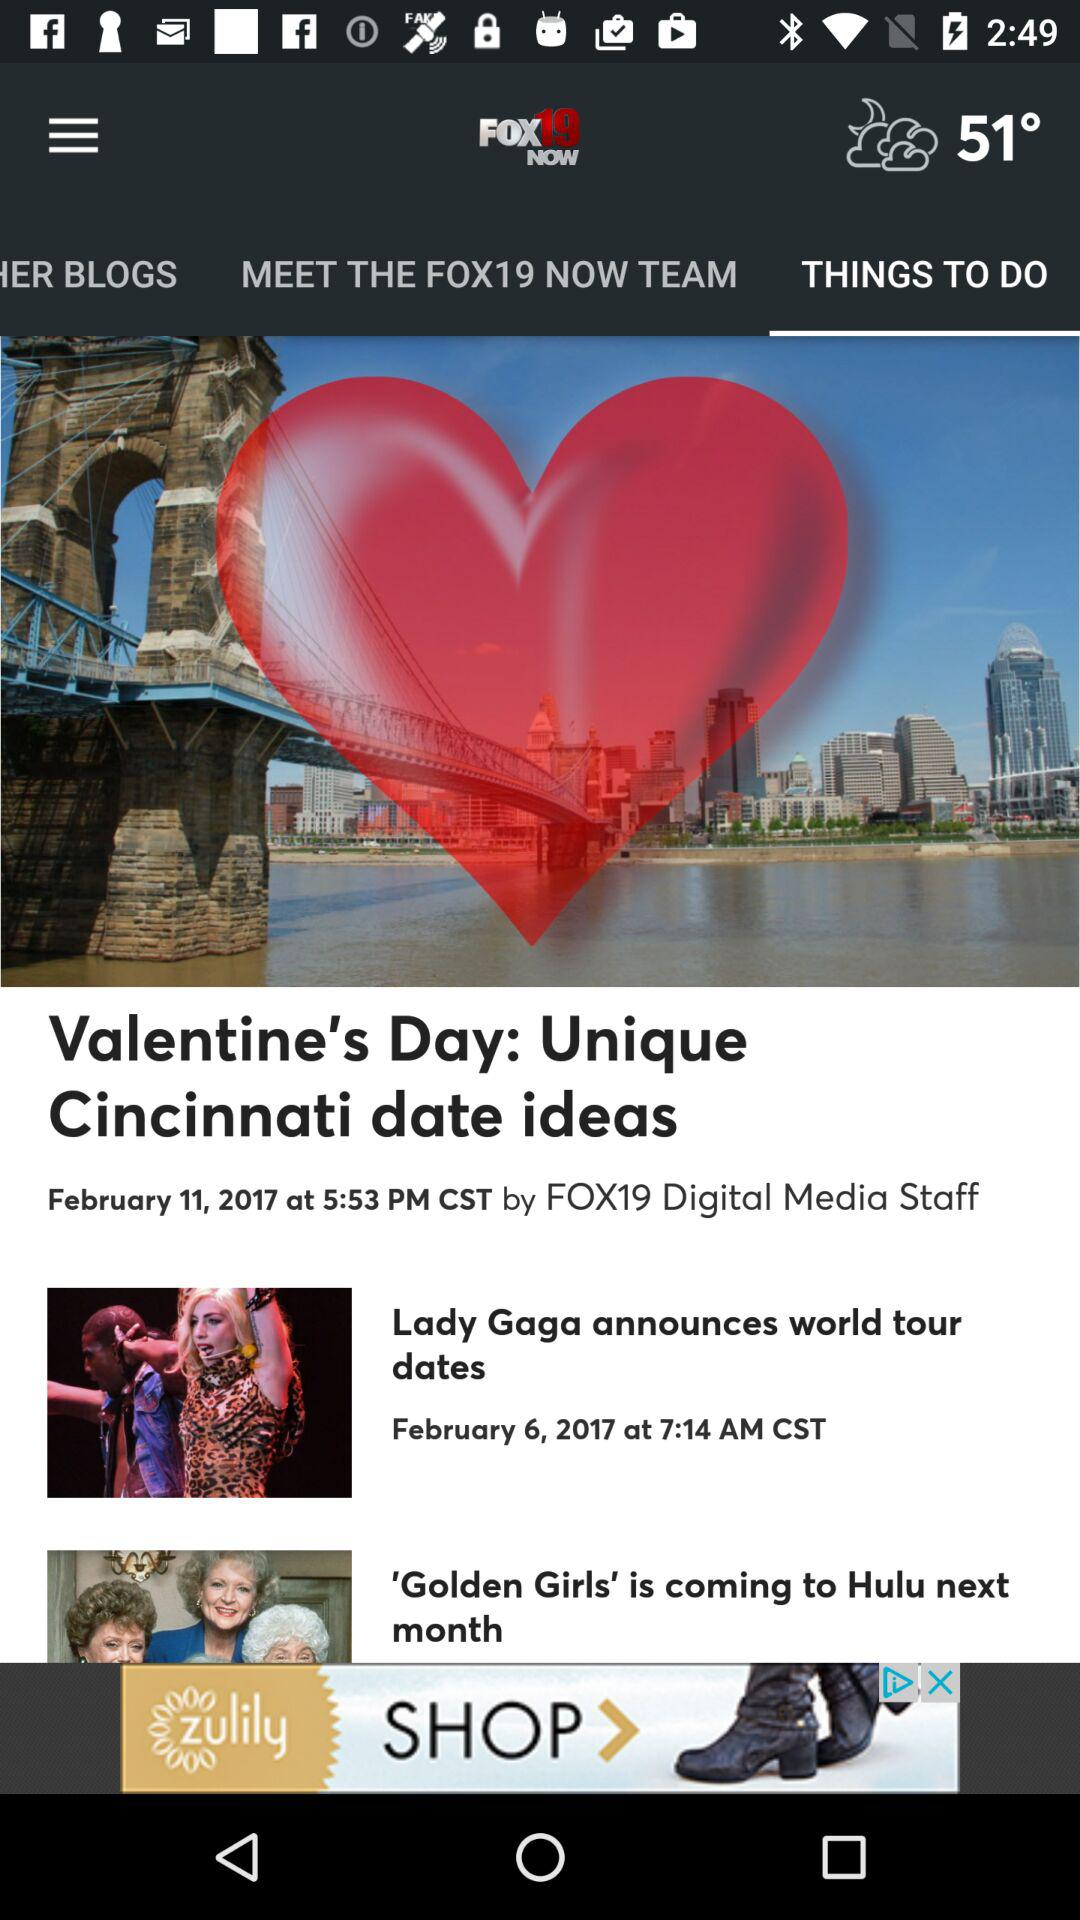Which tab is selected? The selected tab is "THINGS TO DO". 